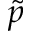Convert formula to latex. <formula><loc_0><loc_0><loc_500><loc_500>\tilde { p }</formula> 